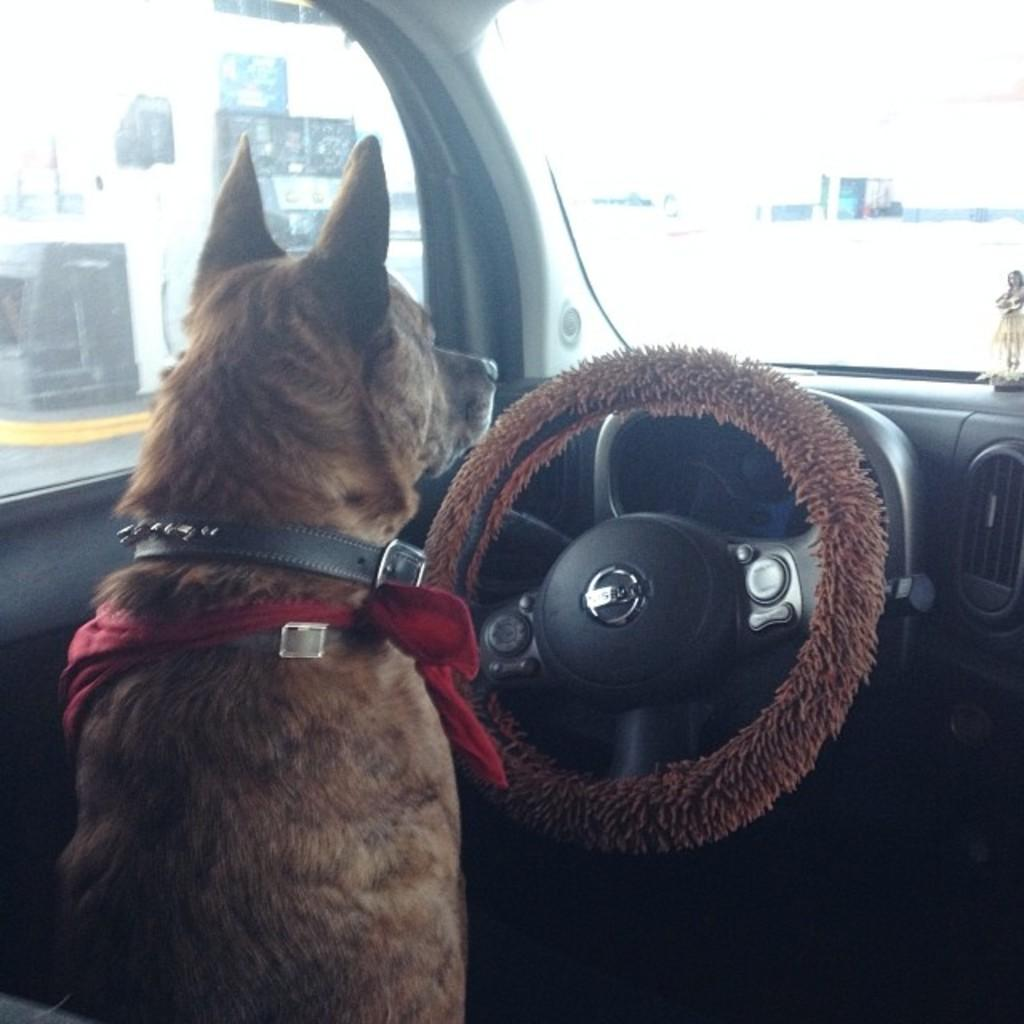What animal can be seen in the image? There is a dog in the image. Where is the dog located in the image? The dog is sitting in the seat of a car. What is the dog positioned in front of? The dog is in front of a steering wheel. What can be seen through the front of the car in the image? There is a windshield in the background of the image. What type of stamp can be seen on the dog's paw in the image? There is no stamp present on the dog's paw in the image. How does the wound on the dog's leg appear to be healing in the image? There is no wound present on the dog's leg in the image. 